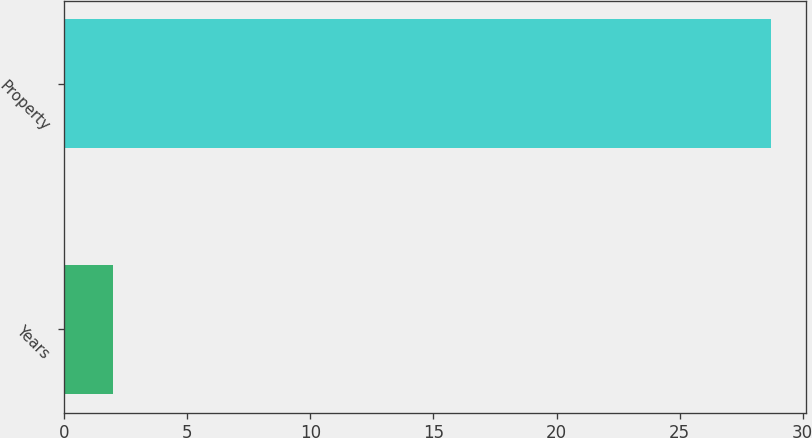Convert chart to OTSL. <chart><loc_0><loc_0><loc_500><loc_500><bar_chart><fcel>Years<fcel>Property<nl><fcel>2<fcel>28.7<nl></chart> 